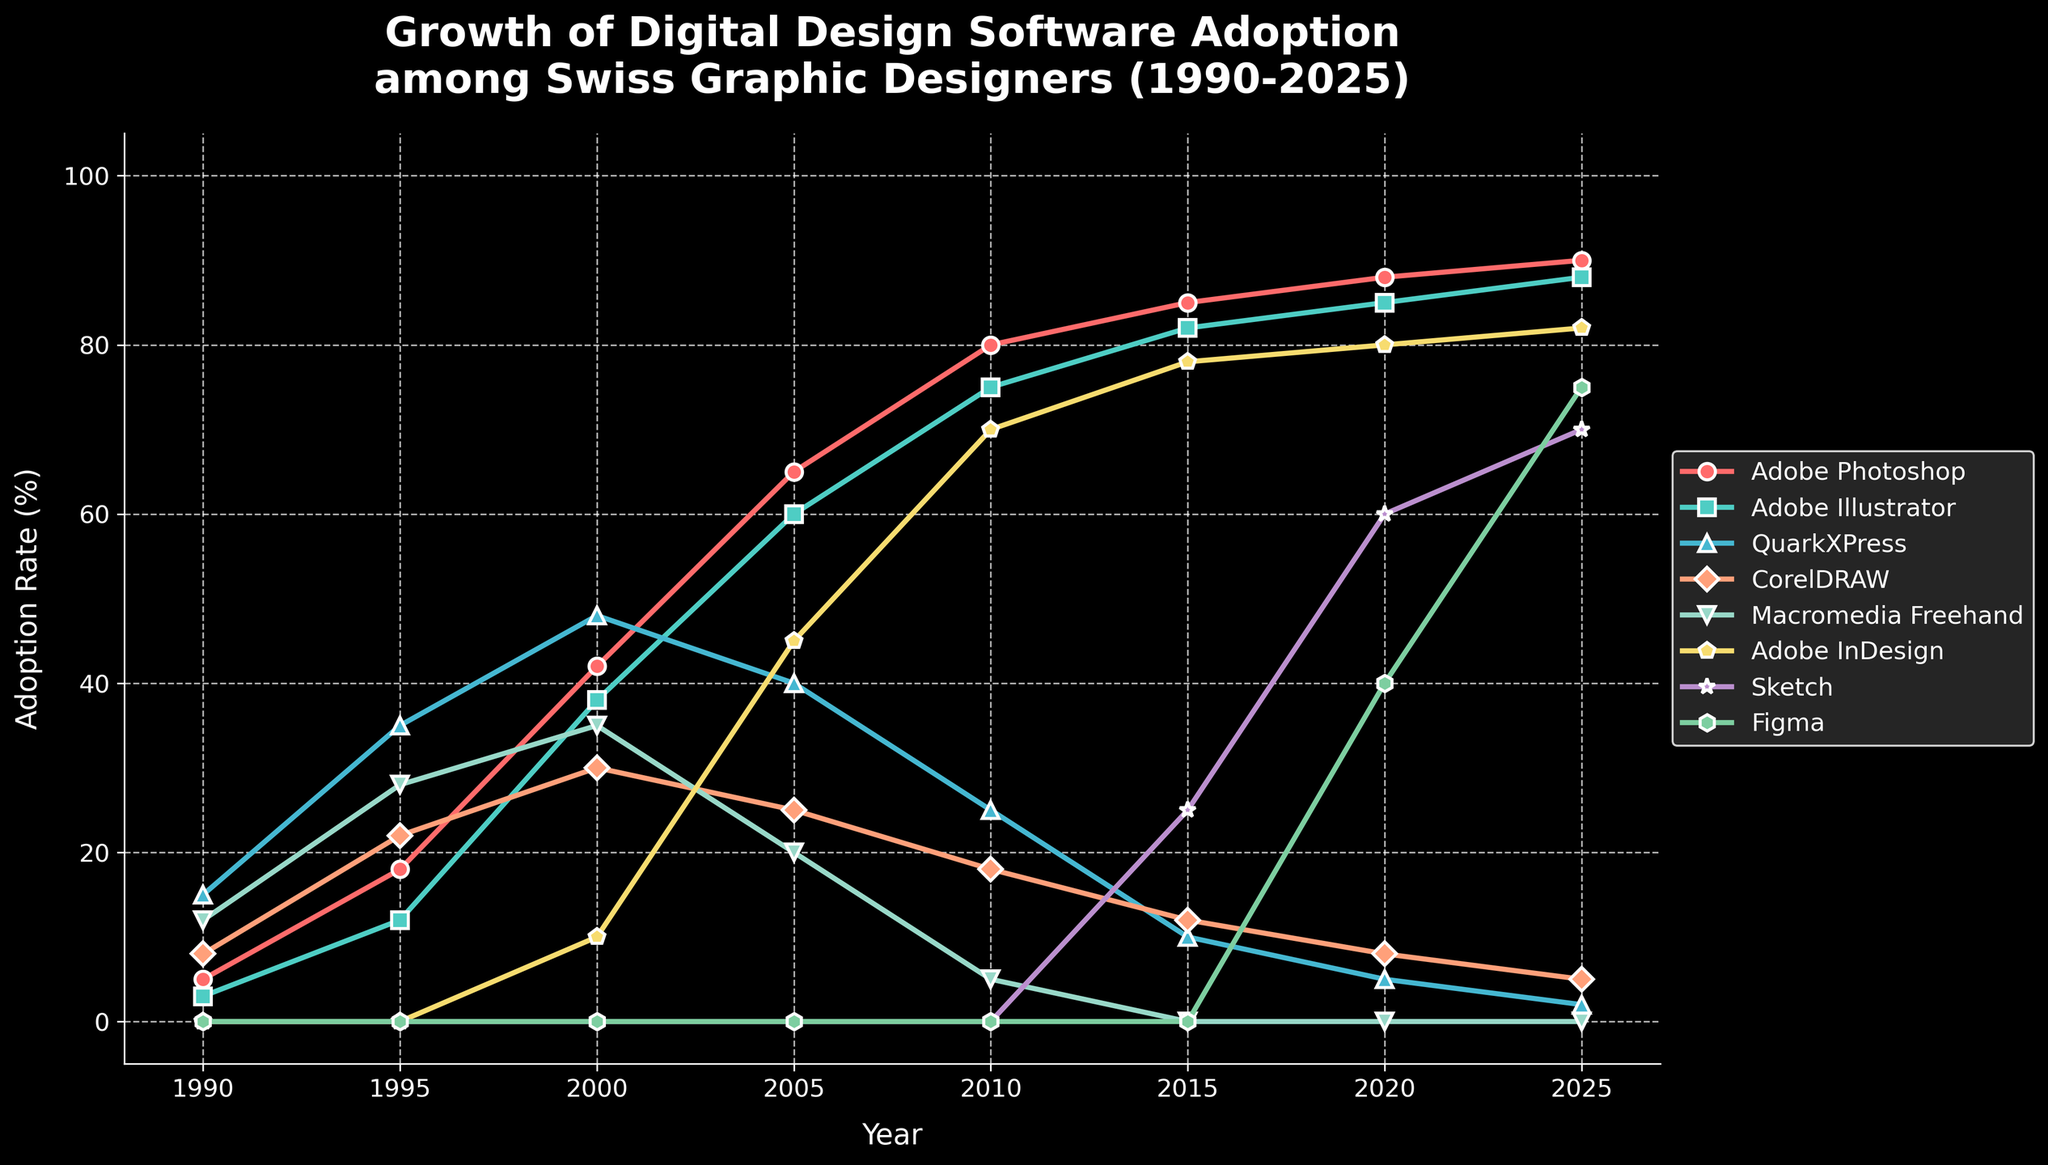Which software had the highest adoption rate consistently from 1990 to 2025? By examining the figure, we see that Adobe Photoshop’s adoption rate remains highest across all years.
Answer: Adobe Photoshop Which software shows the sharpest increase in adoption rate between 1990 and 2000? The figure indicates Adobe Photoshop has a noticeable rise from 5% to 42%, a 37% increase, which is the largest among all the software listed.
Answer: Adobe Photoshop In what year did Adobe InDesign surpass QuarkXPress in adoption rate? In 2005, Adobe InDesign (45%) surpasses QuarkXPress (40%) in terms of adoption rate. This can be deduced by comparing their values across the years shown.
Answer: 2005 Compare the adoption rates of Sketch and Figma in 2020. Which one has a higher rate? In 2020, Sketch has an adoption rate of 60%, while Figma has 40%, making Sketch higher than Figma.
Answer: Sketch Which software(s) had an adoption rate decrease or stagnation after initially increasing up to 2000? Both QuarkXPress and CorelDRAW show a decline after 2000, with QuarkXPress from 48% to 2% and CorelDRAW from 30% to 5%. Macromedia Freehand drops to 0%.
Answer: QuarkXPress, CorelDRAW, Macromedia Freehand What is the average adoption rate of Adobe Illustrator over the entire period shown? The values to average are [3, 12, 38, 60, 75, 82, 85, 88]. Summing them yields 443 and dividing by 8 gives an average of 55.375%.
Answer: 55.375% What is the most recent year where Adobe InDesign had its adoption rate visibly increase, and by how much did it increase? Between 2010 and 2015, Adobe InDesign increases from 70% to 78%, i.e., by 8%. This is evident as 2015 has the last noticeable jump.
Answer: 2015, 8% Which software was discontinued or had zero adoption rate after a certain year? Macromedia Freehand shows adoption until 2010, then it drops to 0% by 2015 and remains there.
Answer: Macromedia Freehand If we sum the adoption rates for Adobe Photoshop, Adobe Illustrator, and Figma in 2025, what is the total? For 2025, Adobe Photoshop (90%), Adobe Illustrator (88%), and Figma (75%) add up to 90 + 88 + 75 = 253%.
Answer: 253% 